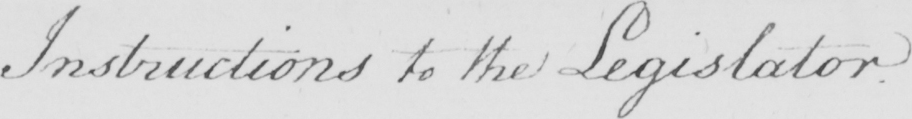Can you read and transcribe this handwriting? Instructions to the Legislator . 